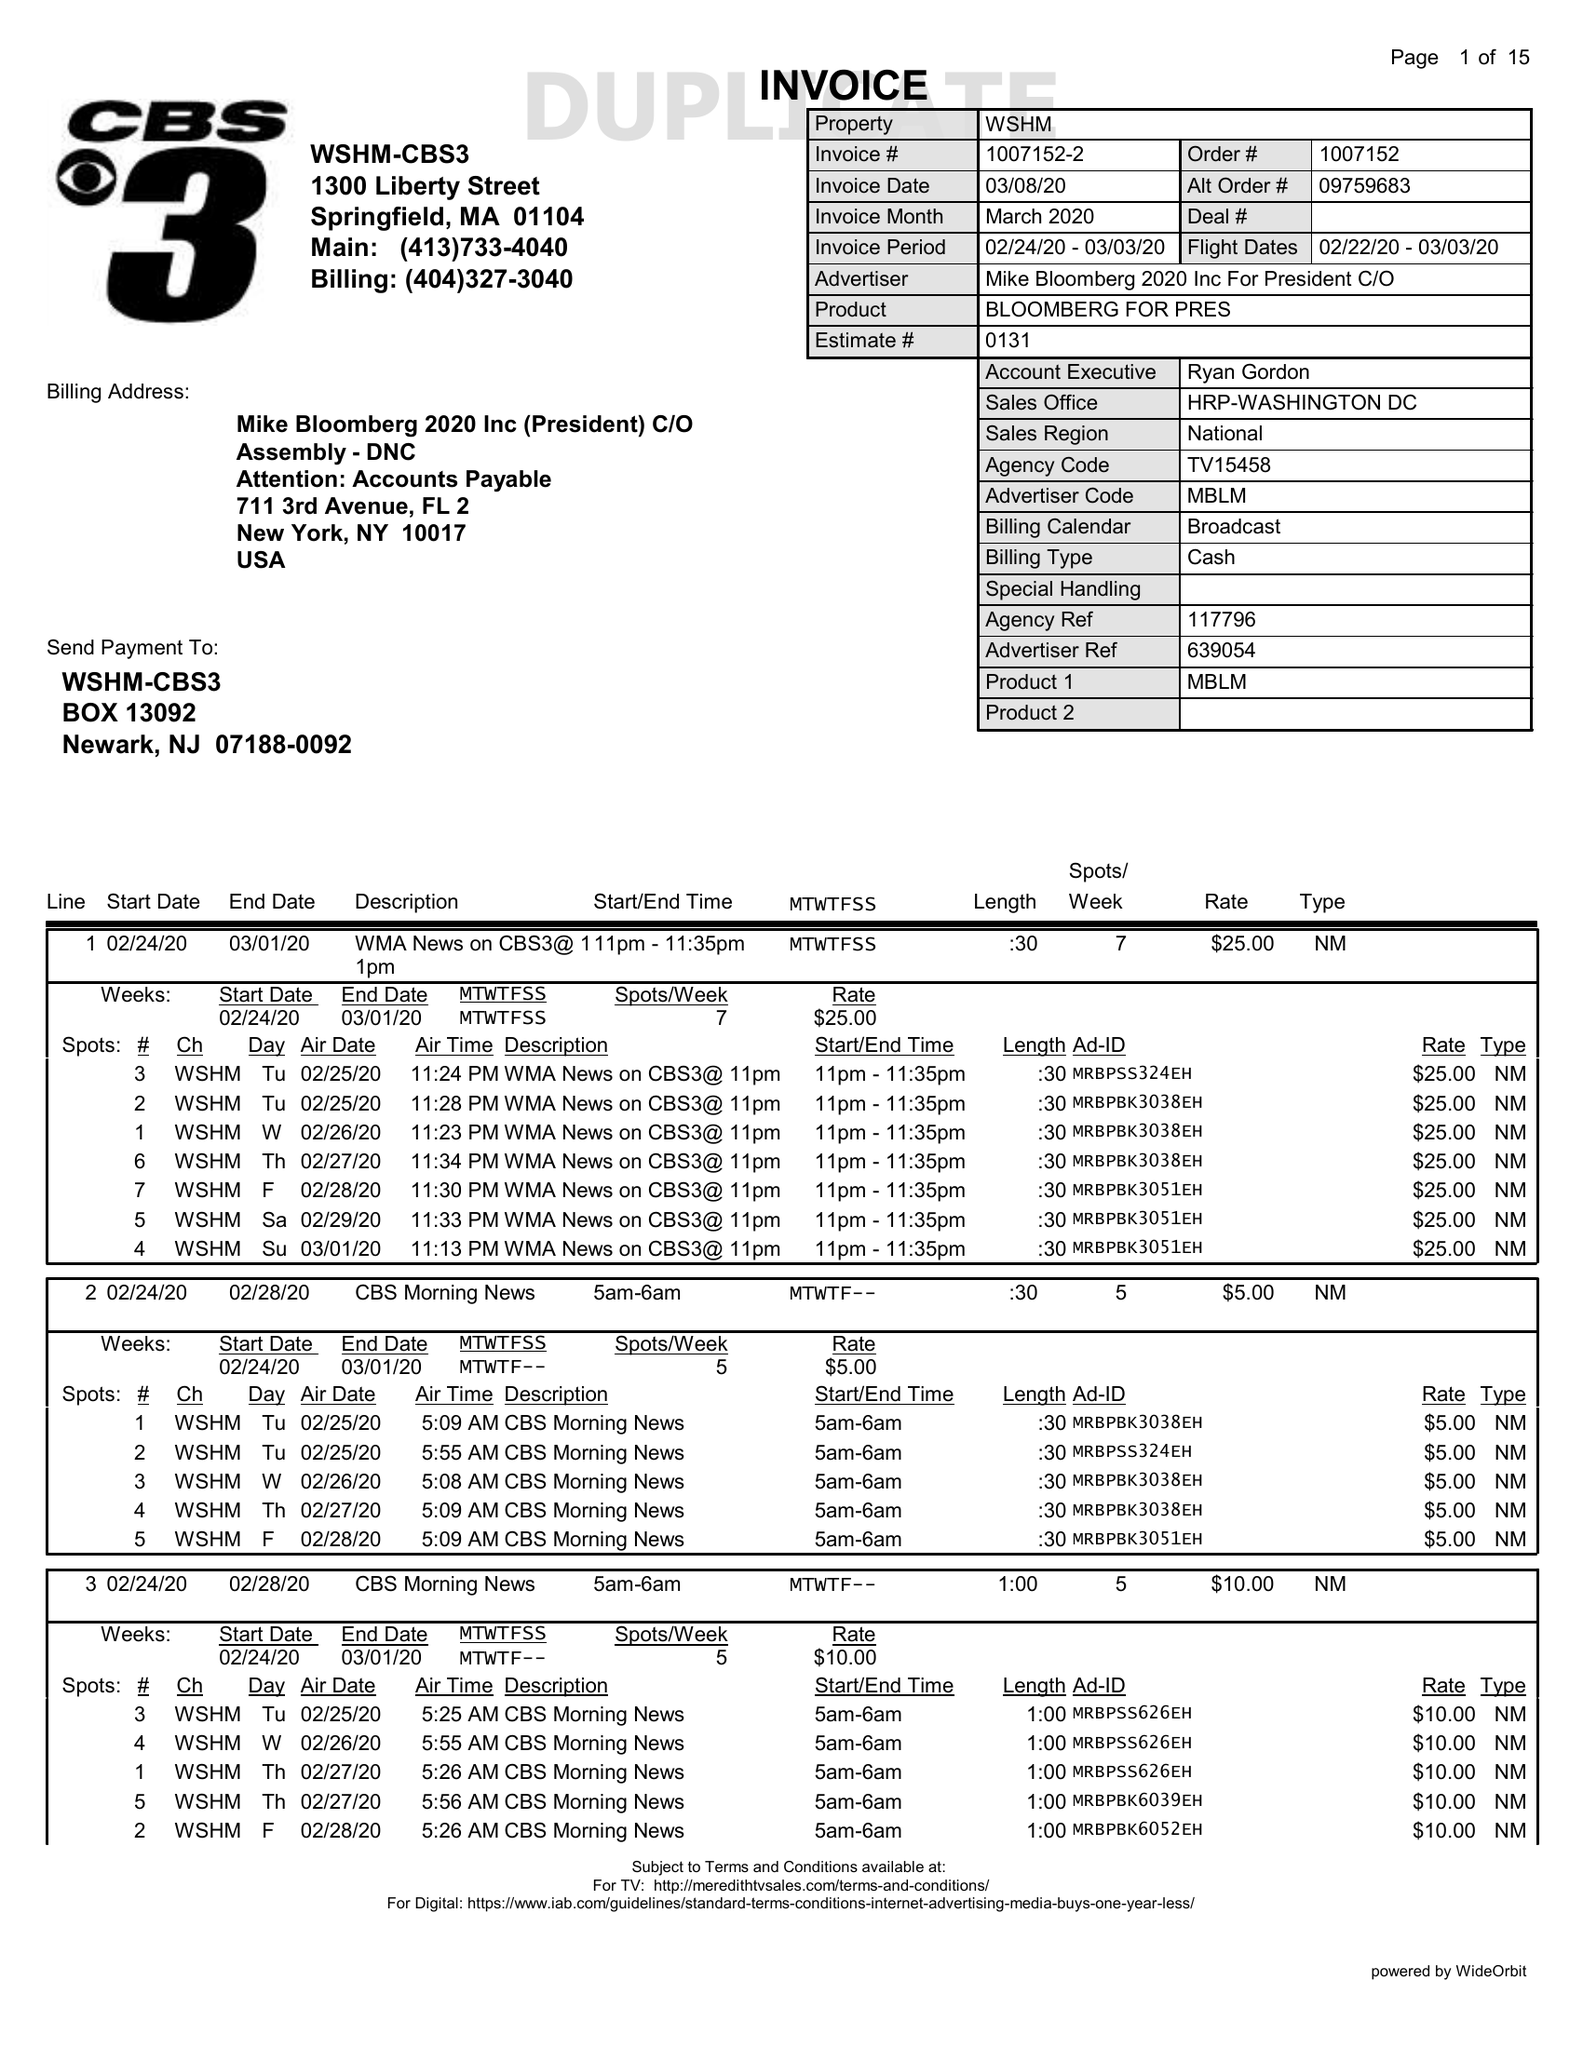What is the value for the flight_from?
Answer the question using a single word or phrase. 02/22/20 